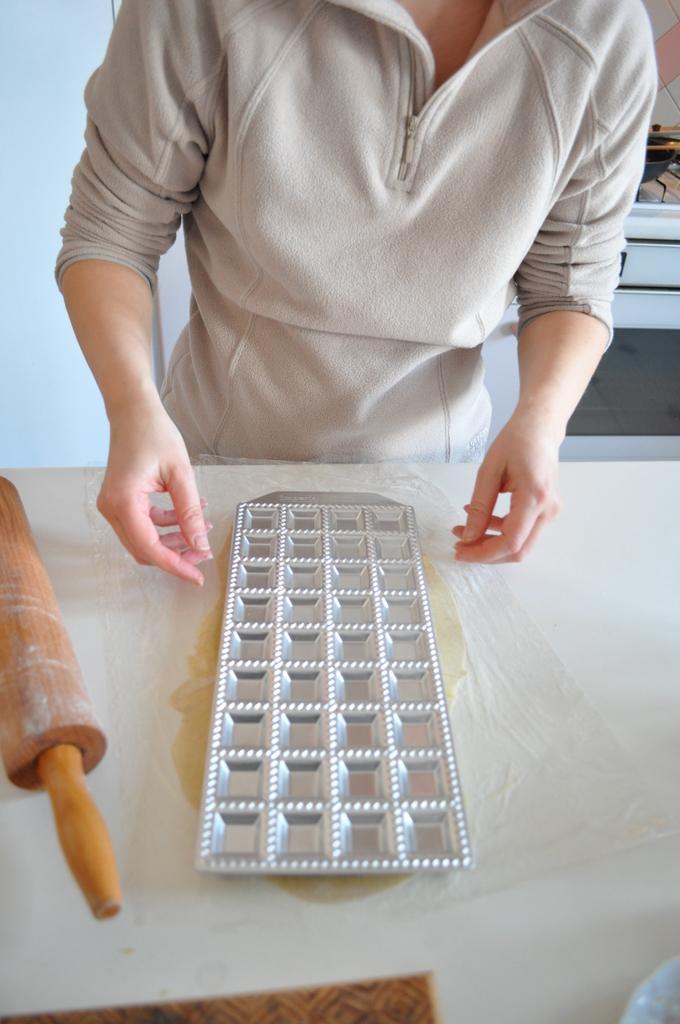How would you summarize this image in a sentence or two? In the picture we can see a table on it, we can see a tray and beside it, we can see a wooden stick and near the table, we can see a person standing and trying to hold the tray. 